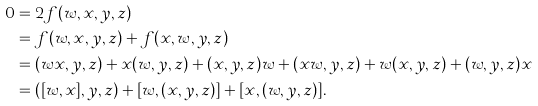Convert formula to latex. <formula><loc_0><loc_0><loc_500><loc_500>0 & = 2 f ( w , x , y , z ) & \\ & = f ( w , x , y , z ) + f ( x , w , y , z ) & \\ & = ( w x , y , z ) + x ( w , y , z ) + ( x , y , z ) w + ( x w , y , z ) + w ( x , y , z ) + ( w , y , z ) x & \\ & = ( [ w , x ] , y , z ) + [ w , ( x , y , z ) ] + [ x , ( w , y , z ) ] . &</formula> 